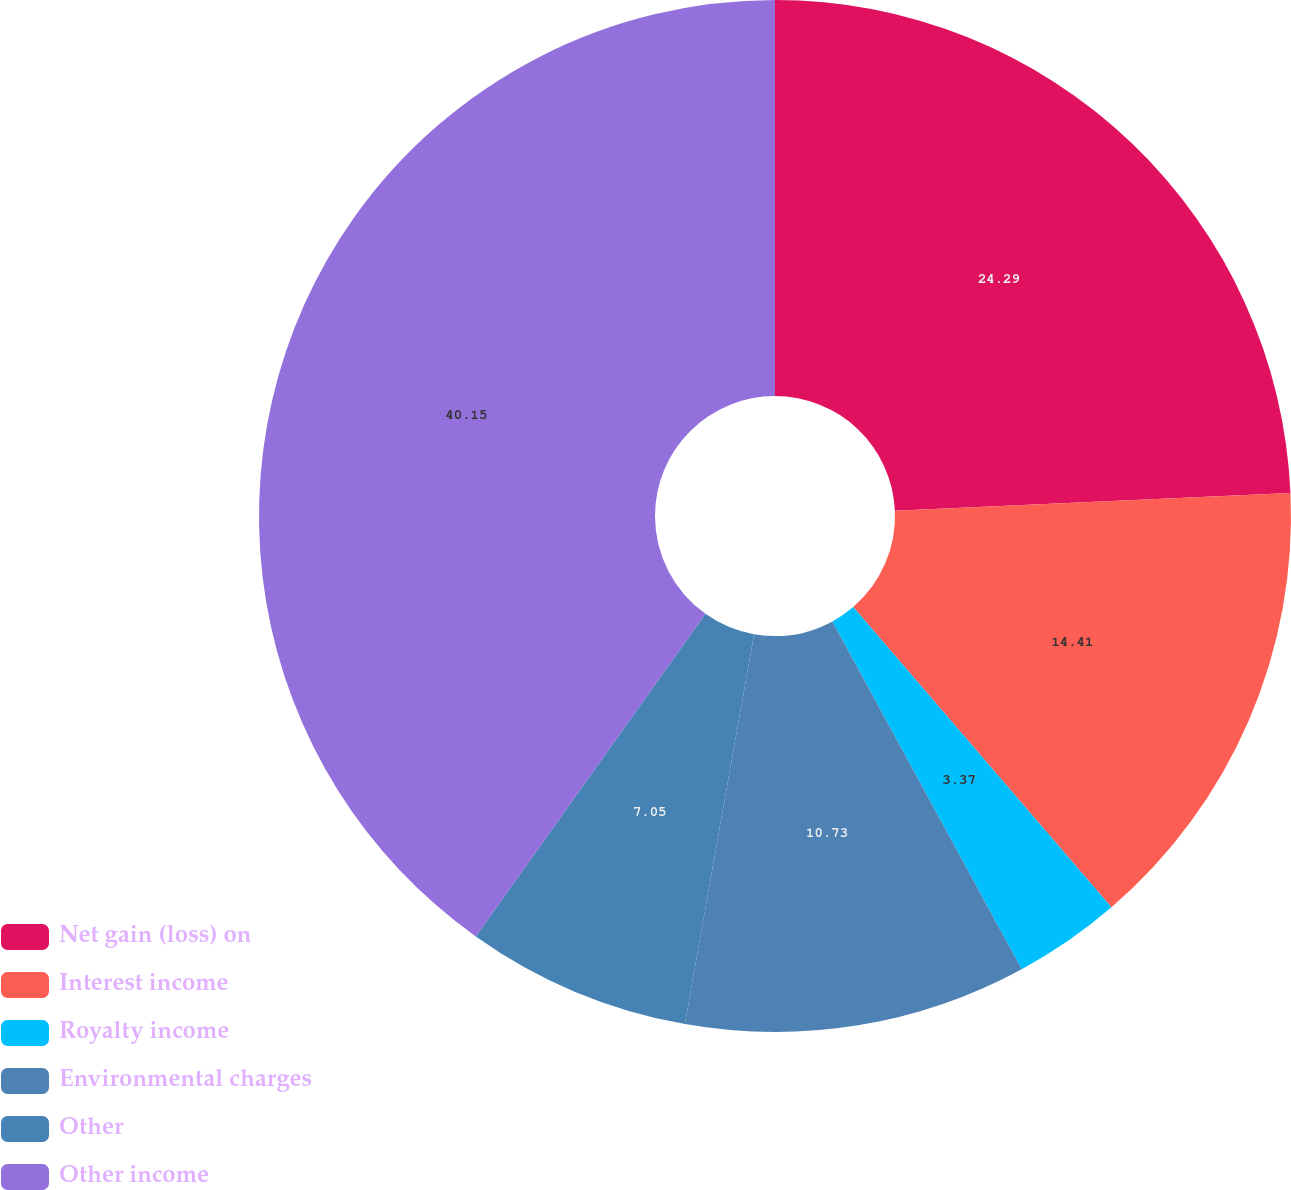Convert chart. <chart><loc_0><loc_0><loc_500><loc_500><pie_chart><fcel>Net gain (loss) on<fcel>Interest income<fcel>Royalty income<fcel>Environmental charges<fcel>Other<fcel>Other income<nl><fcel>24.29%<fcel>14.41%<fcel>3.37%<fcel>10.73%<fcel>7.05%<fcel>40.16%<nl></chart> 